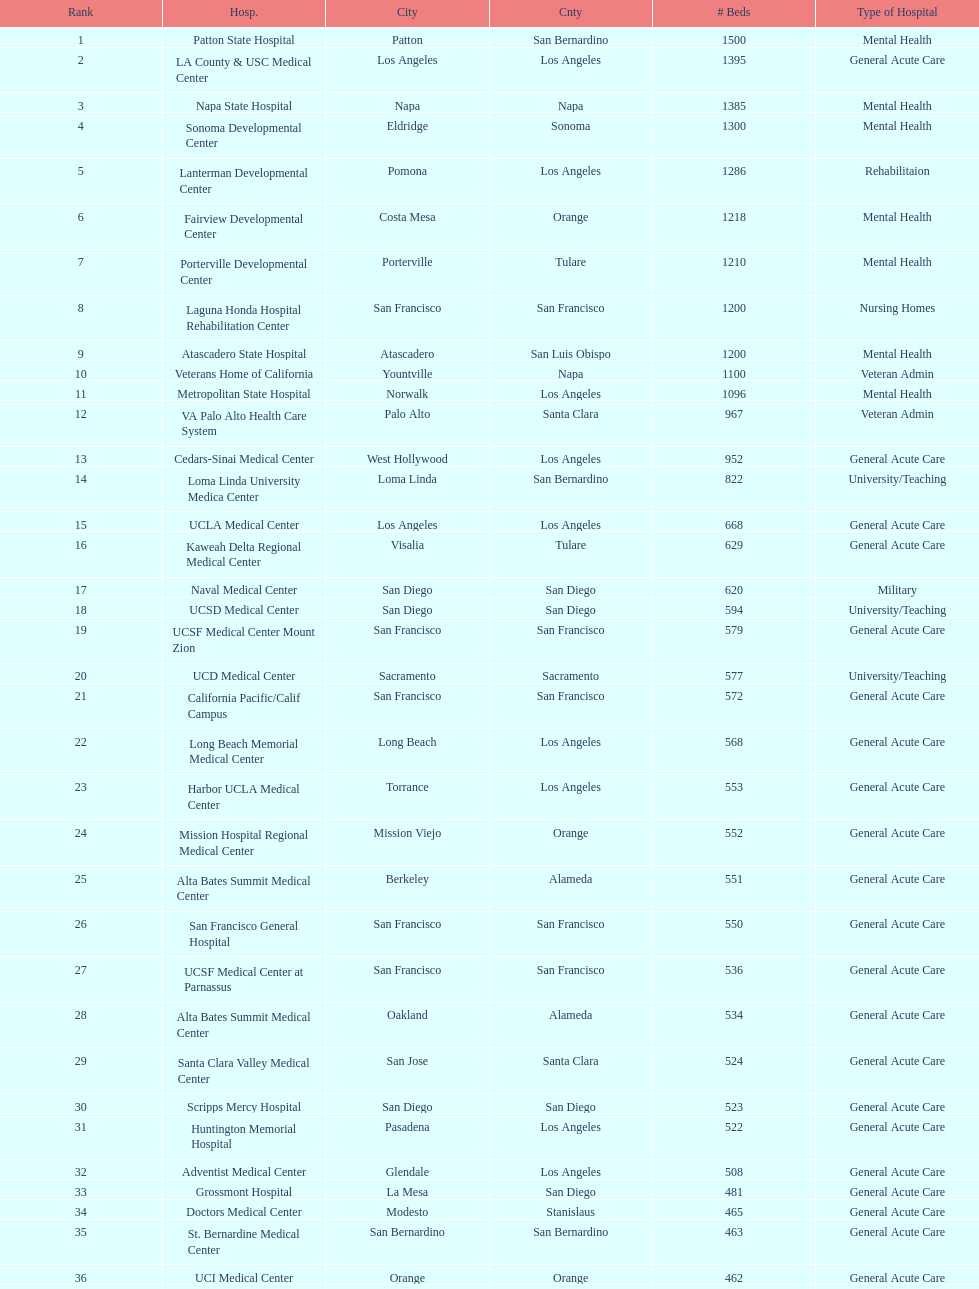How many more general acute care hospitals are there in california than rehabilitation hospitals? 33. 